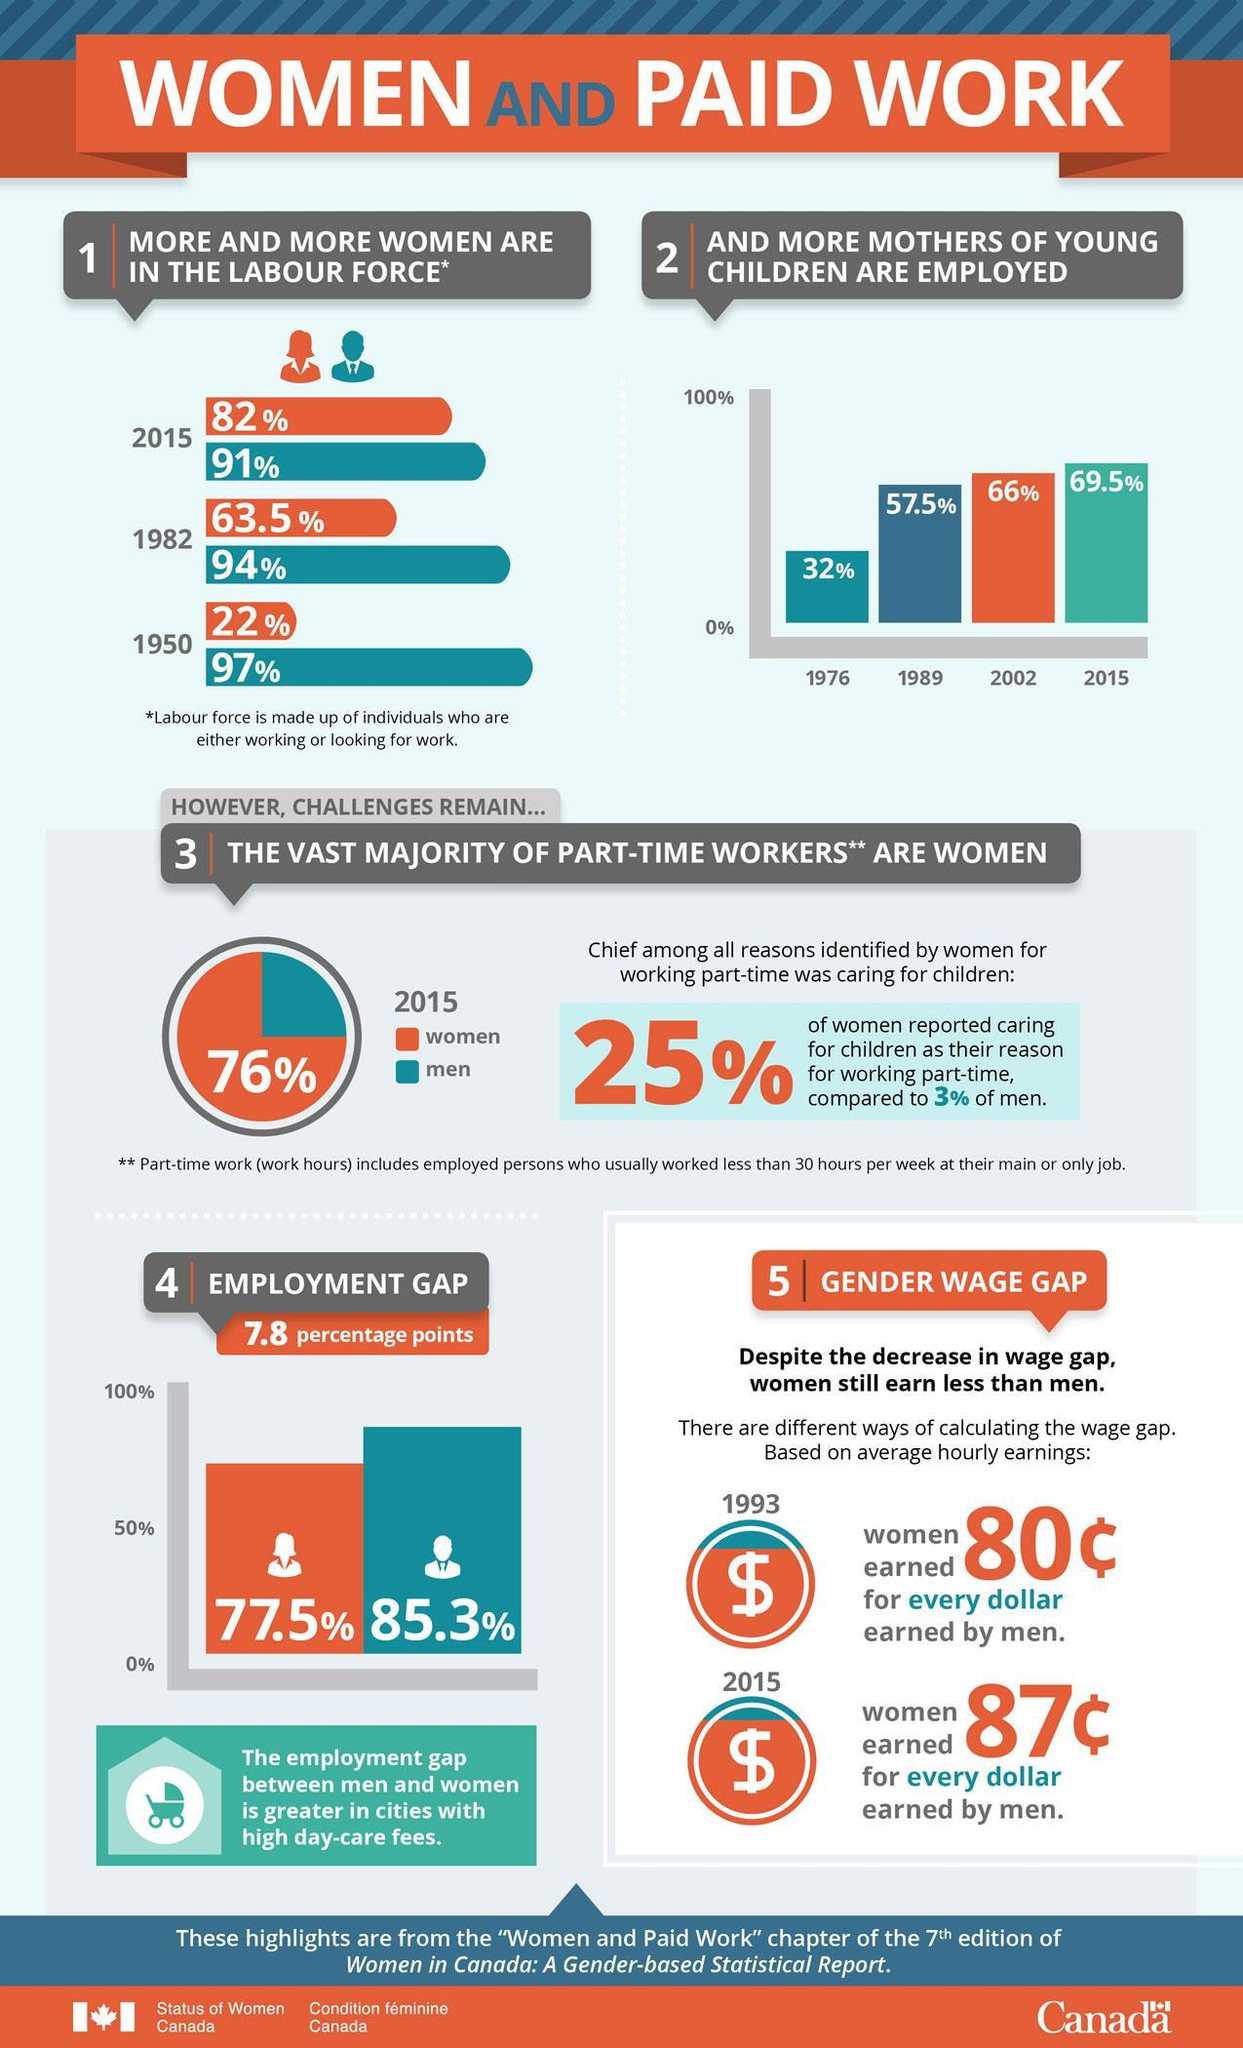What percentage is the employment gap in Canadian women?
Answer the question with a short phrase. 77.5% What percentage of women are in the labour force of Canada in 1982? 63.5% What percentage of part-time workers in Canada are women in 2015? 76% What percentage of part-time workers in Canada are men in 2015? 24% What percentage of men are in the labour force of Canada in 2015? 91% What percentage of Canadian mothers of young children were employed in 2002? 66% 